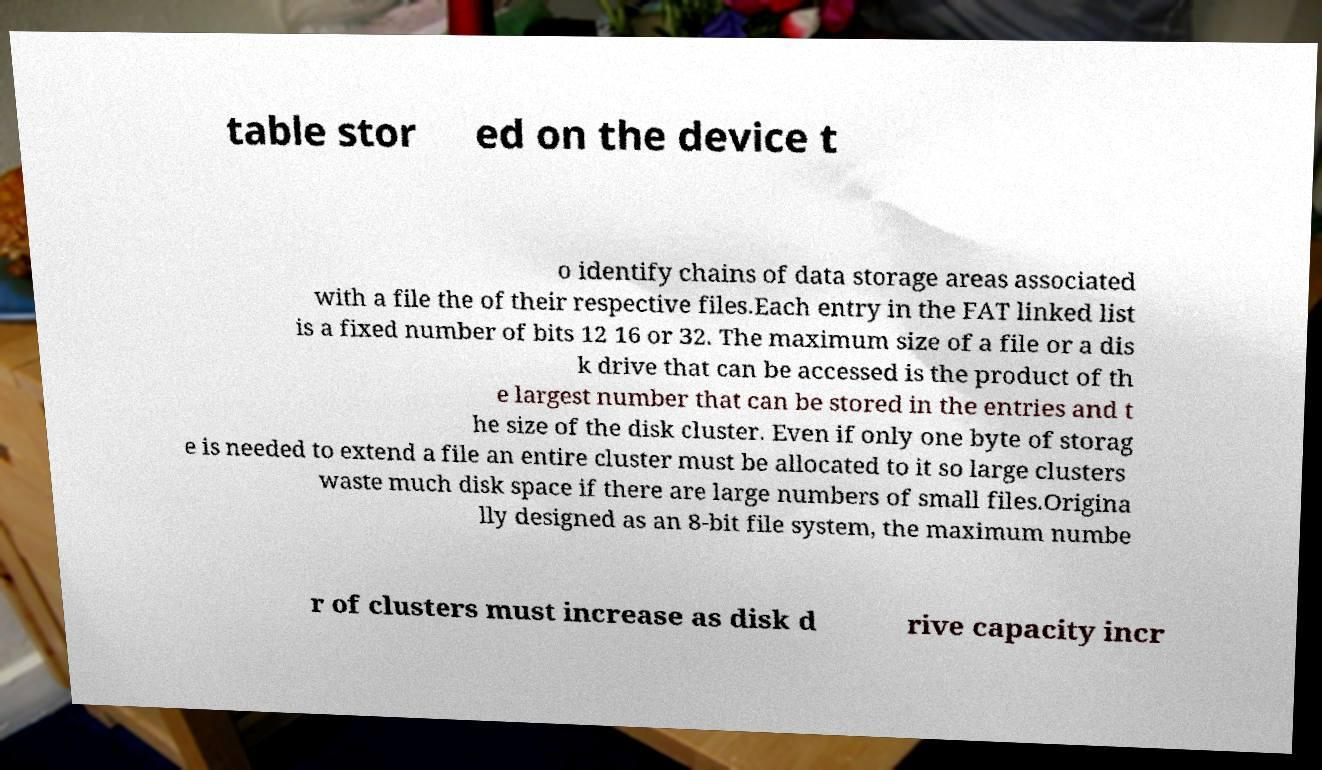Please identify and transcribe the text found in this image. table stor ed on the device t o identify chains of data storage areas associated with a file the of their respective files.Each entry in the FAT linked list is a fixed number of bits 12 16 or 32. The maximum size of a file or a dis k drive that can be accessed is the product of th e largest number that can be stored in the entries and t he size of the disk cluster. Even if only one byte of storag e is needed to extend a file an entire cluster must be allocated to it so large clusters waste much disk space if there are large numbers of small files.Origina lly designed as an 8-bit file system, the maximum numbe r of clusters must increase as disk d rive capacity incr 